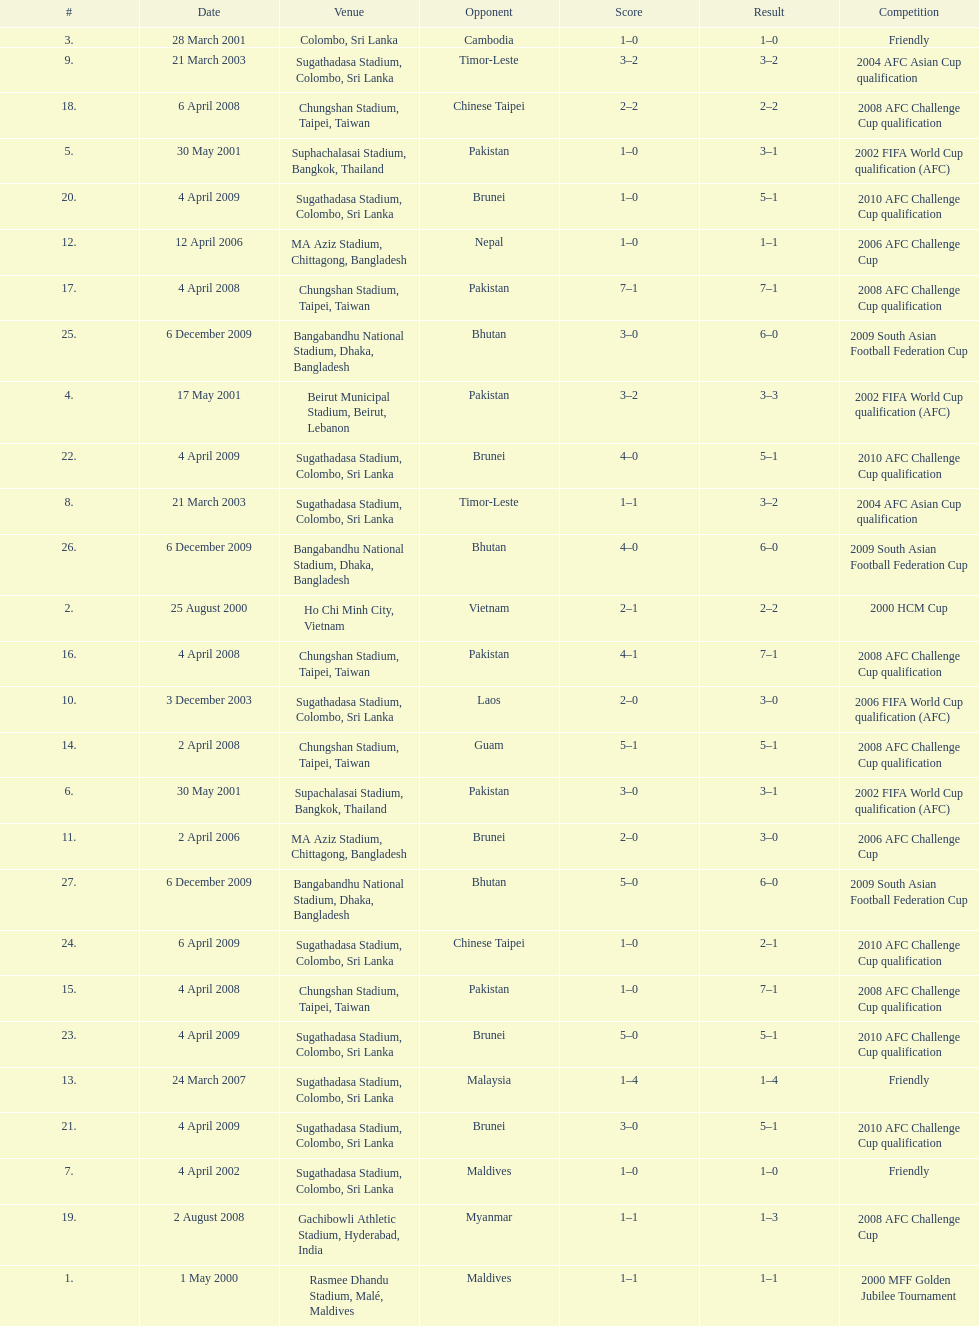What is the number of games played against vietnam? 1. 